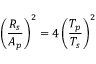Convert formula to latex. <formula><loc_0><loc_0><loc_500><loc_500>\left ( \frac { R _ { s } } { A _ { p } } \right ) ^ { 2 } = 4 \left ( \frac { T _ { p } } { T _ { s } } \right ) ^ { 2 }</formula> 